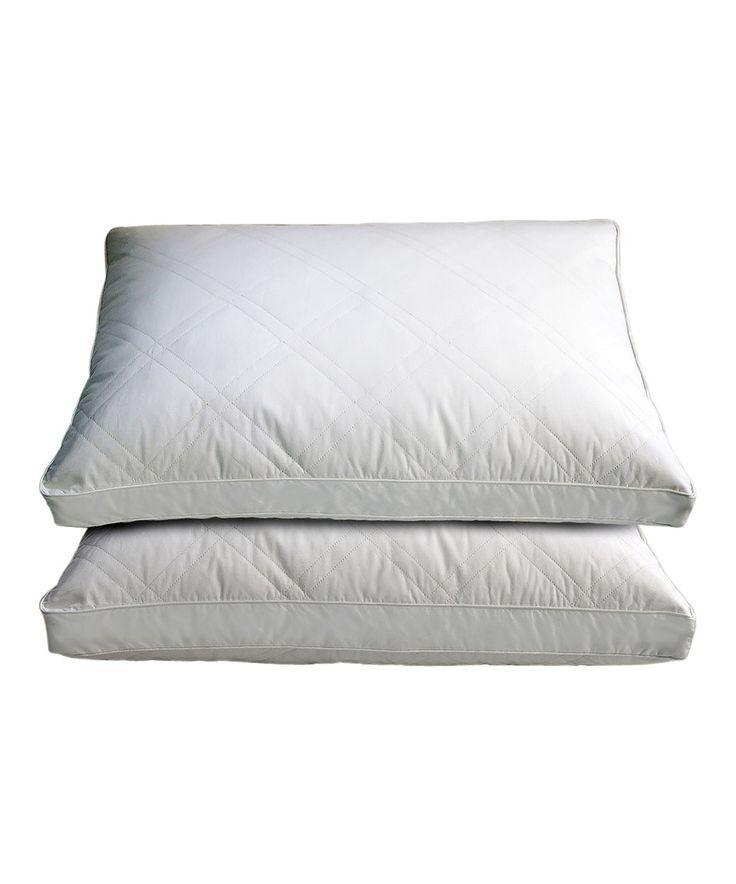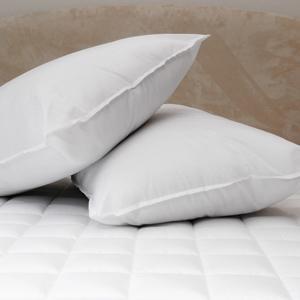The first image is the image on the left, the second image is the image on the right. Examine the images to the left and right. Is the description "The right image contains two plain colored pillows." accurate? Answer yes or no. Yes. The first image is the image on the left, the second image is the image on the right. Analyze the images presented: Is the assertion "Each image contains a stack of two white pillows, and no pillow stacks are sitting on a textured surface." valid? Answer yes or no. No. 